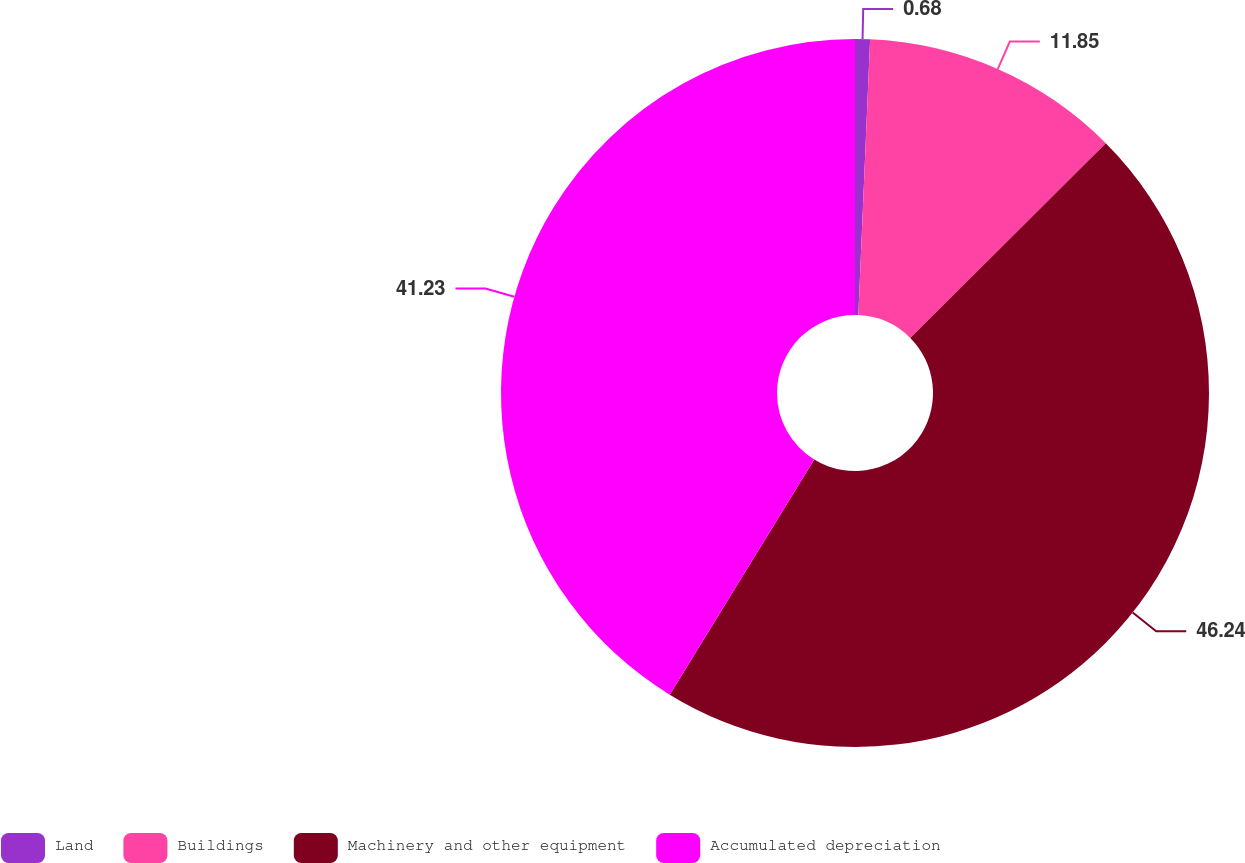<chart> <loc_0><loc_0><loc_500><loc_500><pie_chart><fcel>Land<fcel>Buildings<fcel>Machinery and other equipment<fcel>Accumulated depreciation<nl><fcel>0.68%<fcel>11.85%<fcel>46.23%<fcel>41.23%<nl></chart> 